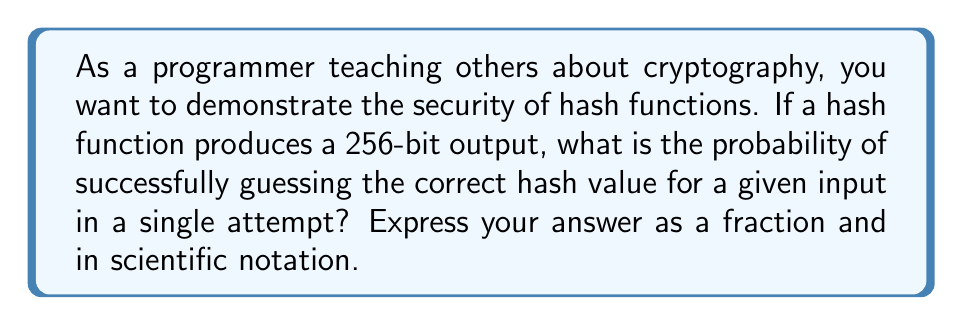Can you solve this math problem? Let's approach this step-by-step:

1) A 256-bit hash output means there are $2^{256}$ possible hash values.

2) Each bit can be either 0 or 1, so for 256 bits, we have:
   $$2 \times 2 \times 2 \times ... \text{ (256 times) } = 2^{256}$$

3) The probability of guessing the correct hash is 1 divided by the total number of possible hash values:

   $$P(\text{correct guess}) = \frac{1}{2^{256}}$$

4) This fraction can be expressed in scientific notation as follows:
   
   $$\frac{1}{2^{256}} = 1 \times 2^{-256} \approx 8.636 \times 10^{-78}$$

5) To put this in perspective, this probability is extremely small. It's much smaller than the probability of randomly selecting a specific atom from all the atoms in the observable universe.

This demonstrates the strength of cryptographic hash functions against brute-force attacks, as guessing becomes practically impossible with large bit lengths.
Answer: $\frac{1}{2^{256}}$ or $8.636 \times 10^{-78}$ 